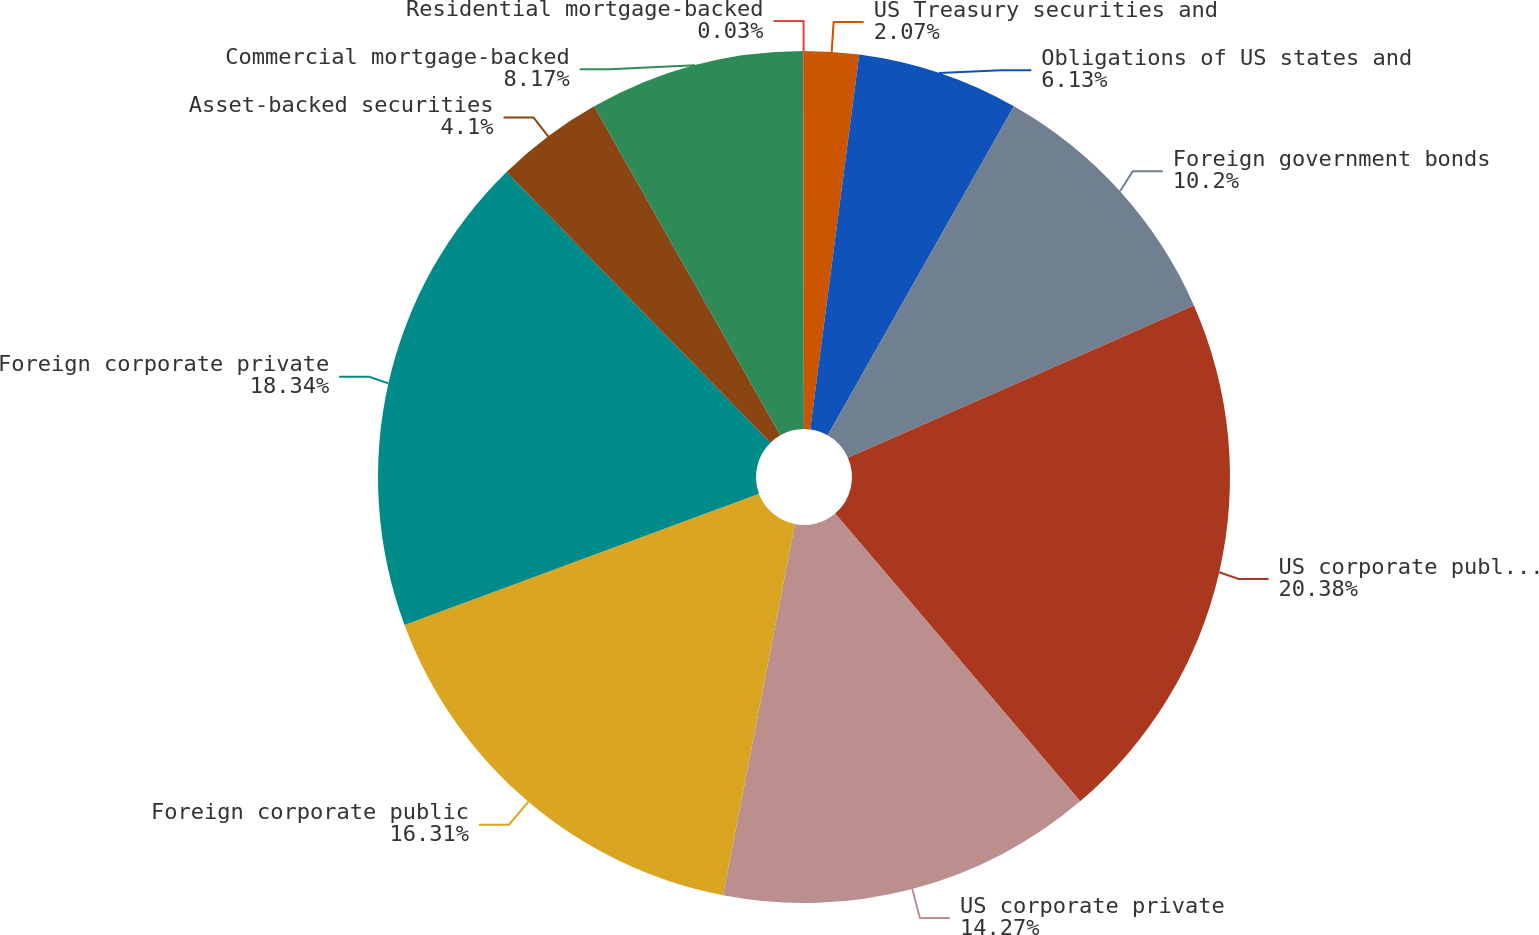Convert chart. <chart><loc_0><loc_0><loc_500><loc_500><pie_chart><fcel>US Treasury securities and<fcel>Obligations of US states and<fcel>Foreign government bonds<fcel>US corporate public securities<fcel>US corporate private<fcel>Foreign corporate public<fcel>Foreign corporate private<fcel>Asset-backed securities<fcel>Commercial mortgage-backed<fcel>Residential mortgage-backed<nl><fcel>2.07%<fcel>6.13%<fcel>10.2%<fcel>20.37%<fcel>14.27%<fcel>16.31%<fcel>18.34%<fcel>4.1%<fcel>8.17%<fcel>0.03%<nl></chart> 